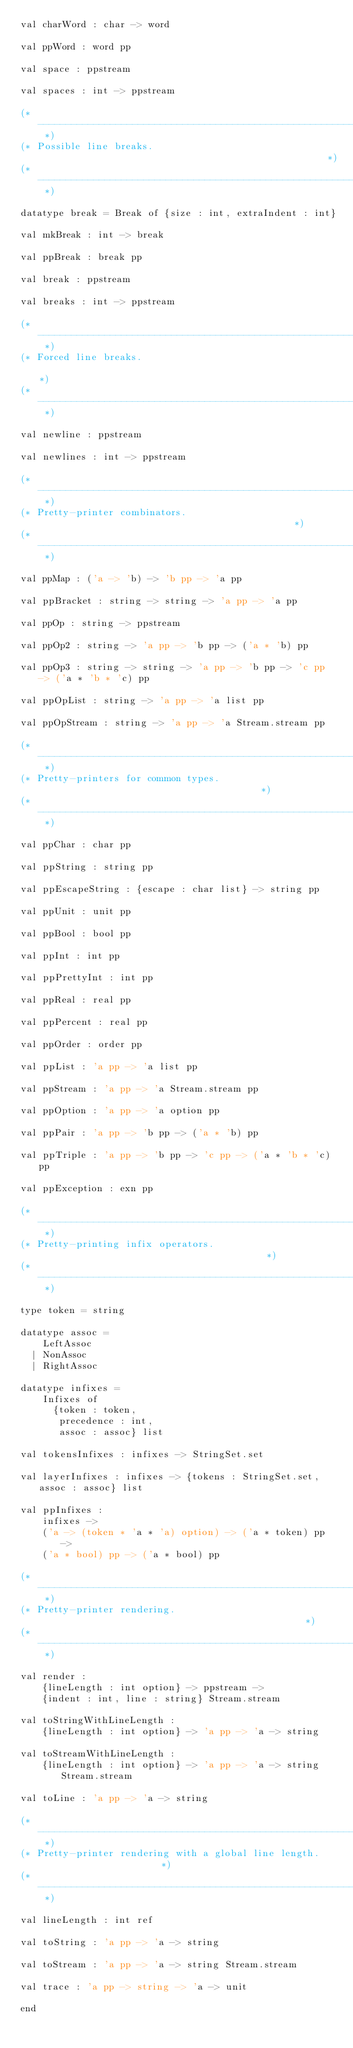<code> <loc_0><loc_0><loc_500><loc_500><_SML_>val charWord : char -> word

val ppWord : word pp

val space : ppstream

val spaces : int -> ppstream

(* ------------------------------------------------------------------------- *)
(* Possible line breaks.                                                     *)
(* ------------------------------------------------------------------------- *)

datatype break = Break of {size : int, extraIndent : int}

val mkBreak : int -> break

val ppBreak : break pp

val break : ppstream

val breaks : int -> ppstream

(* ------------------------------------------------------------------------- *)
(* Forced line breaks.                                                       *)
(* ------------------------------------------------------------------------- *)

val newline : ppstream

val newlines : int -> ppstream

(* ------------------------------------------------------------------------- *)
(* Pretty-printer combinators.                                               *)
(* ------------------------------------------------------------------------- *)

val ppMap : ('a -> 'b) -> 'b pp -> 'a pp

val ppBracket : string -> string -> 'a pp -> 'a pp

val ppOp : string -> ppstream

val ppOp2 : string -> 'a pp -> 'b pp -> ('a * 'b) pp

val ppOp3 : string -> string -> 'a pp -> 'b pp -> 'c pp -> ('a * 'b * 'c) pp

val ppOpList : string -> 'a pp -> 'a list pp

val ppOpStream : string -> 'a pp -> 'a Stream.stream pp

(* ------------------------------------------------------------------------- *)
(* Pretty-printers for common types.                                         *)
(* ------------------------------------------------------------------------- *)

val ppChar : char pp

val ppString : string pp

val ppEscapeString : {escape : char list} -> string pp

val ppUnit : unit pp

val ppBool : bool pp

val ppInt : int pp

val ppPrettyInt : int pp

val ppReal : real pp

val ppPercent : real pp

val ppOrder : order pp

val ppList : 'a pp -> 'a list pp

val ppStream : 'a pp -> 'a Stream.stream pp

val ppOption : 'a pp -> 'a option pp

val ppPair : 'a pp -> 'b pp -> ('a * 'b) pp

val ppTriple : 'a pp -> 'b pp -> 'c pp -> ('a * 'b * 'c) pp

val ppException : exn pp

(* ------------------------------------------------------------------------- *)
(* Pretty-printing infix operators.                                          *)
(* ------------------------------------------------------------------------- *)

type token = string

datatype assoc =
    LeftAssoc
  | NonAssoc
  | RightAssoc

datatype infixes =
    Infixes of
      {token : token,
       precedence : int,
       assoc : assoc} list

val tokensInfixes : infixes -> StringSet.set

val layerInfixes : infixes -> {tokens : StringSet.set, assoc : assoc} list

val ppInfixes :
    infixes ->
    ('a -> (token * 'a * 'a) option) -> ('a * token) pp ->
    ('a * bool) pp -> ('a * bool) pp

(* ------------------------------------------------------------------------- *)
(* Pretty-printer rendering.                                                 *)
(* ------------------------------------------------------------------------- *)

val render :
    {lineLength : int option} -> ppstream ->
    {indent : int, line : string} Stream.stream

val toStringWithLineLength :
    {lineLength : int option} -> 'a pp -> 'a -> string

val toStreamWithLineLength :
    {lineLength : int option} -> 'a pp -> 'a -> string Stream.stream

val toLine : 'a pp -> 'a -> string

(* ------------------------------------------------------------------------- *)
(* Pretty-printer rendering with a global line length.                       *)
(* ------------------------------------------------------------------------- *)

val lineLength : int ref

val toString : 'a pp -> 'a -> string

val toStream : 'a pp -> 'a -> string Stream.stream

val trace : 'a pp -> string -> 'a -> unit

end
</code> 